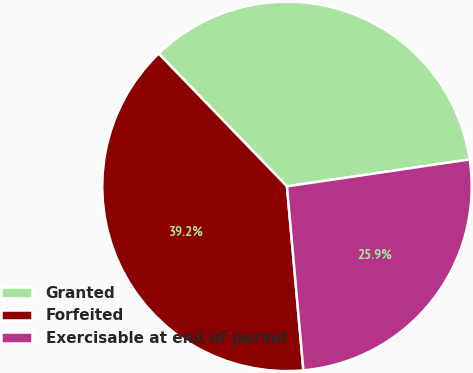Convert chart. <chart><loc_0><loc_0><loc_500><loc_500><pie_chart><fcel>Granted<fcel>Forfeited<fcel>Exercisable at end of period<nl><fcel>34.89%<fcel>39.19%<fcel>25.91%<nl></chart> 